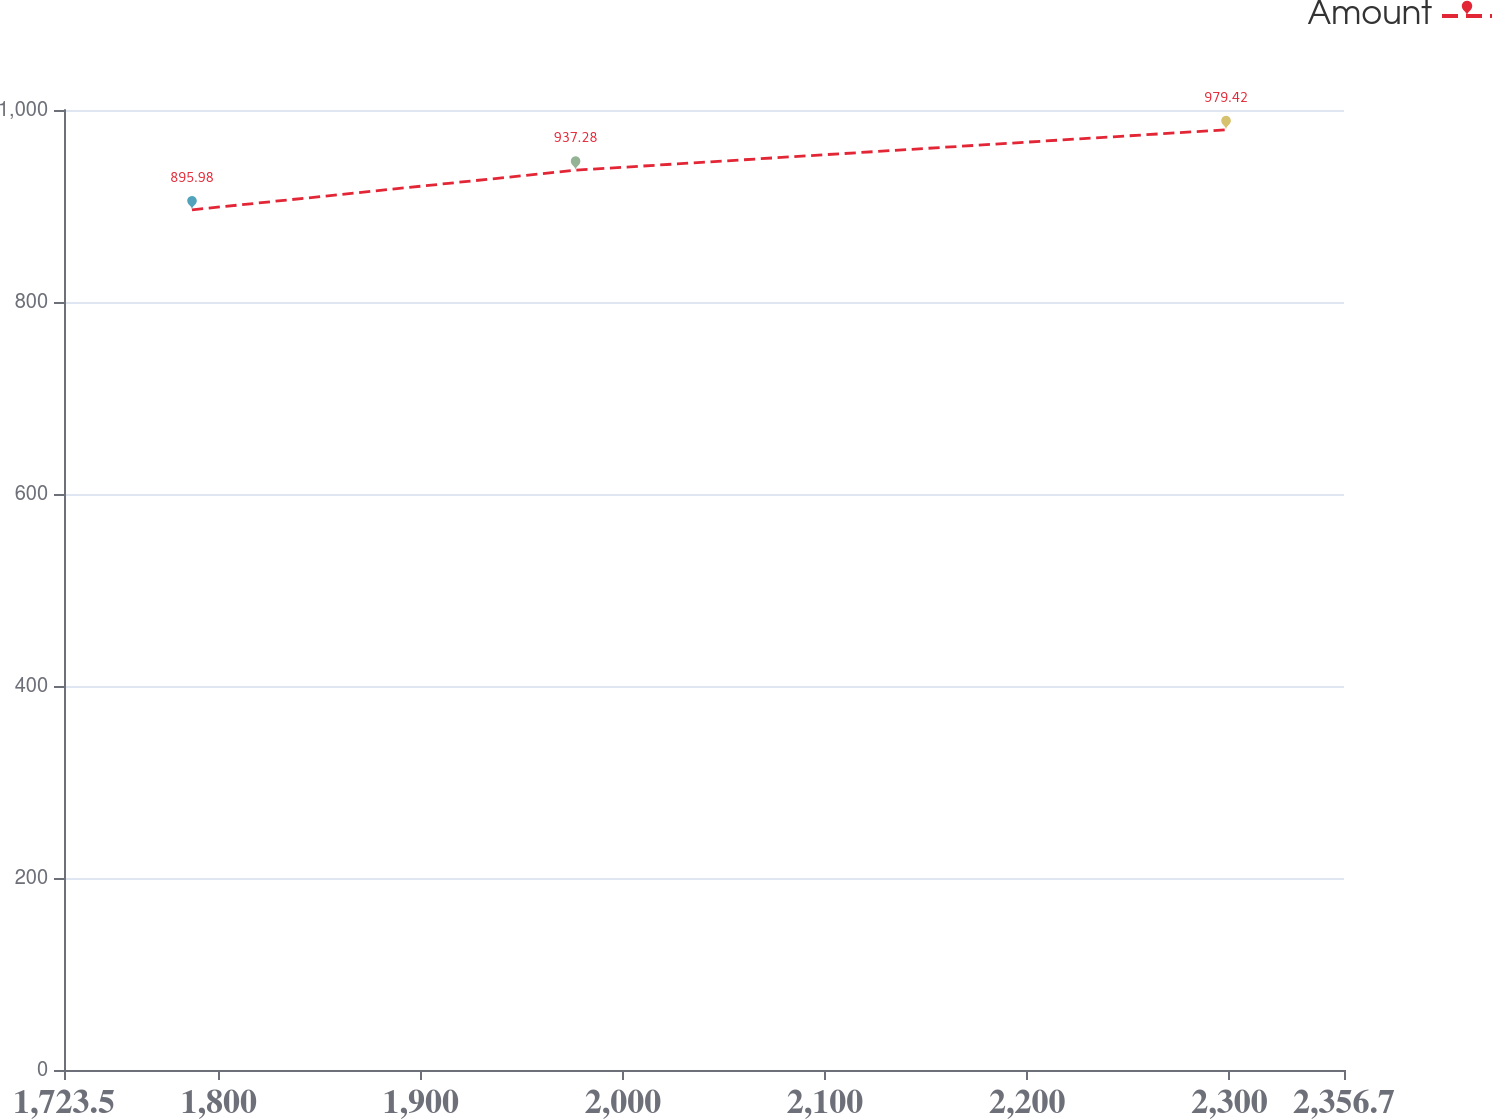Convert chart. <chart><loc_0><loc_0><loc_500><loc_500><line_chart><ecel><fcel>Amount<nl><fcel>1786.82<fcel>895.98<nl><fcel>1976.58<fcel>937.28<nl><fcel>2298.34<fcel>979.42<nl><fcel>2359.18<fcel>1087.06<nl><fcel>2420.02<fcel>960.31<nl></chart> 